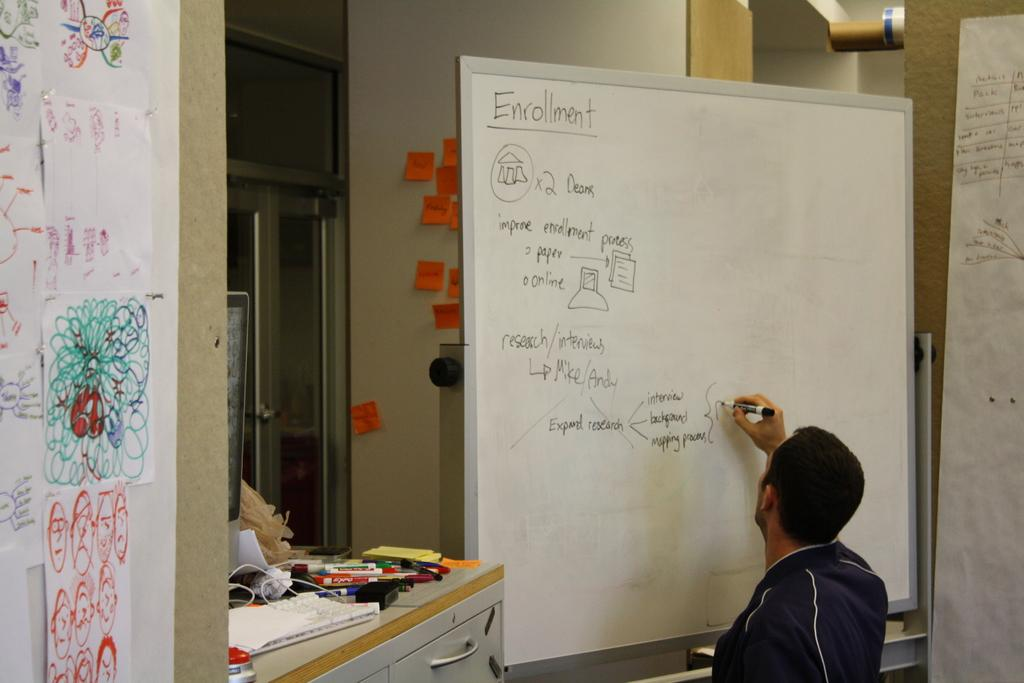<image>
Describe the image concisely. A man writes on a dry erase board about Enrollment with a black marker 